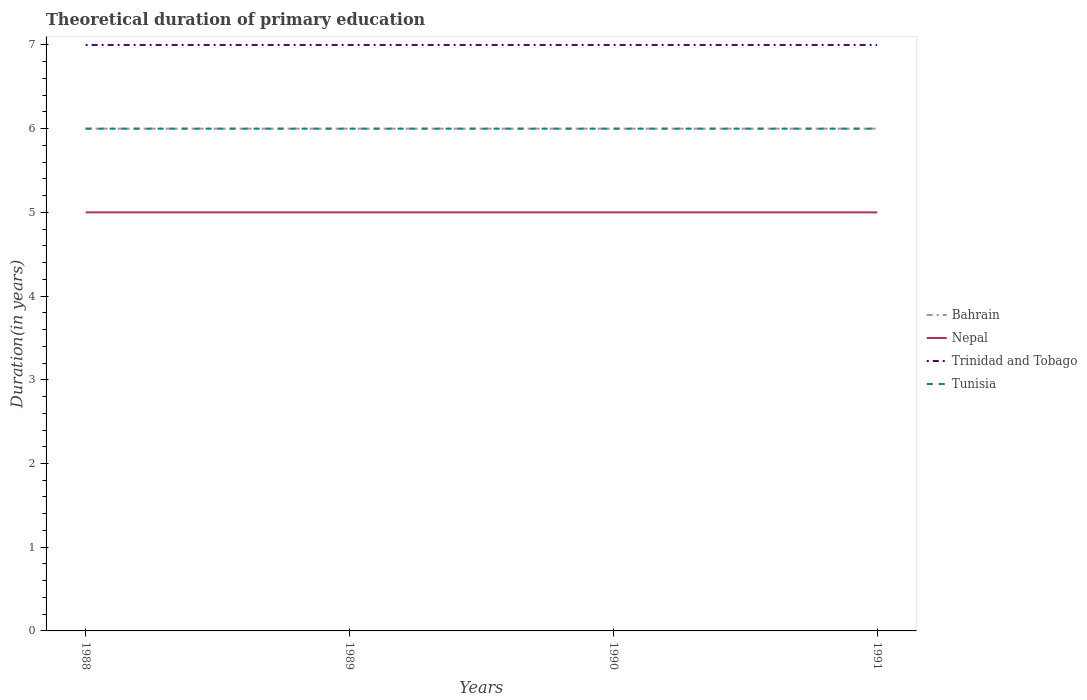Does the line corresponding to Tunisia intersect with the line corresponding to Nepal?
Your answer should be very brief. No. Is the number of lines equal to the number of legend labels?
Make the answer very short. Yes. Across all years, what is the maximum total theoretical duration of primary education in Trinidad and Tobago?
Give a very brief answer. 7. In which year was the total theoretical duration of primary education in Trinidad and Tobago maximum?
Make the answer very short. 1988. What is the total total theoretical duration of primary education in Tunisia in the graph?
Give a very brief answer. 0. What is the difference between the highest and the second highest total theoretical duration of primary education in Nepal?
Make the answer very short. 0. What is the difference between the highest and the lowest total theoretical duration of primary education in Bahrain?
Give a very brief answer. 0. How many lines are there?
Give a very brief answer. 4. How many years are there in the graph?
Offer a terse response. 4. Where does the legend appear in the graph?
Offer a terse response. Center right. What is the title of the graph?
Offer a terse response. Theoretical duration of primary education. What is the label or title of the Y-axis?
Your answer should be compact. Duration(in years). What is the Duration(in years) of Bahrain in 1988?
Give a very brief answer. 6. What is the Duration(in years) of Nepal in 1988?
Give a very brief answer. 5. What is the Duration(in years) in Bahrain in 1989?
Keep it short and to the point. 6. What is the Duration(in years) of Trinidad and Tobago in 1989?
Your answer should be very brief. 7. What is the Duration(in years) in Bahrain in 1990?
Ensure brevity in your answer.  6. What is the Duration(in years) in Trinidad and Tobago in 1990?
Give a very brief answer. 7. Across all years, what is the maximum Duration(in years) of Bahrain?
Offer a terse response. 6. Across all years, what is the maximum Duration(in years) in Tunisia?
Offer a very short reply. 6. Across all years, what is the minimum Duration(in years) of Bahrain?
Your answer should be very brief. 6. Across all years, what is the minimum Duration(in years) of Nepal?
Ensure brevity in your answer.  5. Across all years, what is the minimum Duration(in years) of Tunisia?
Your answer should be compact. 6. What is the total Duration(in years) in Nepal in the graph?
Provide a short and direct response. 20. What is the total Duration(in years) in Trinidad and Tobago in the graph?
Your answer should be compact. 28. What is the difference between the Duration(in years) in Nepal in 1988 and that in 1989?
Provide a succinct answer. 0. What is the difference between the Duration(in years) in Tunisia in 1988 and that in 1989?
Offer a terse response. 0. What is the difference between the Duration(in years) in Bahrain in 1988 and that in 1990?
Keep it short and to the point. 0. What is the difference between the Duration(in years) in Nepal in 1988 and that in 1990?
Ensure brevity in your answer.  0. What is the difference between the Duration(in years) in Trinidad and Tobago in 1988 and that in 1990?
Provide a short and direct response. 0. What is the difference between the Duration(in years) in Trinidad and Tobago in 1988 and that in 1991?
Offer a very short reply. 0. What is the difference between the Duration(in years) in Tunisia in 1988 and that in 1991?
Keep it short and to the point. 0. What is the difference between the Duration(in years) of Trinidad and Tobago in 1989 and that in 1990?
Ensure brevity in your answer.  0. What is the difference between the Duration(in years) of Tunisia in 1989 and that in 1990?
Make the answer very short. 0. What is the difference between the Duration(in years) of Bahrain in 1989 and that in 1991?
Keep it short and to the point. 0. What is the difference between the Duration(in years) of Nepal in 1989 and that in 1991?
Provide a short and direct response. 0. What is the difference between the Duration(in years) in Tunisia in 1989 and that in 1991?
Provide a succinct answer. 0. What is the difference between the Duration(in years) in Tunisia in 1990 and that in 1991?
Offer a very short reply. 0. What is the difference between the Duration(in years) in Bahrain in 1988 and the Duration(in years) in Nepal in 1989?
Make the answer very short. 1. What is the difference between the Duration(in years) of Bahrain in 1988 and the Duration(in years) of Tunisia in 1989?
Ensure brevity in your answer.  0. What is the difference between the Duration(in years) of Nepal in 1988 and the Duration(in years) of Trinidad and Tobago in 1989?
Your answer should be very brief. -2. What is the difference between the Duration(in years) in Nepal in 1988 and the Duration(in years) in Tunisia in 1989?
Keep it short and to the point. -1. What is the difference between the Duration(in years) of Bahrain in 1988 and the Duration(in years) of Trinidad and Tobago in 1990?
Your answer should be compact. -1. What is the difference between the Duration(in years) of Nepal in 1988 and the Duration(in years) of Tunisia in 1990?
Your answer should be compact. -1. What is the difference between the Duration(in years) in Bahrain in 1988 and the Duration(in years) in Tunisia in 1991?
Your response must be concise. 0. What is the difference between the Duration(in years) in Nepal in 1988 and the Duration(in years) in Tunisia in 1991?
Offer a very short reply. -1. What is the difference between the Duration(in years) of Trinidad and Tobago in 1988 and the Duration(in years) of Tunisia in 1991?
Provide a succinct answer. 1. What is the difference between the Duration(in years) in Nepal in 1989 and the Duration(in years) in Trinidad and Tobago in 1990?
Offer a terse response. -2. What is the difference between the Duration(in years) in Nepal in 1989 and the Duration(in years) in Tunisia in 1990?
Keep it short and to the point. -1. What is the difference between the Duration(in years) of Nepal in 1989 and the Duration(in years) of Trinidad and Tobago in 1991?
Make the answer very short. -2. What is the difference between the Duration(in years) in Nepal in 1989 and the Duration(in years) in Tunisia in 1991?
Your answer should be compact. -1. What is the difference between the Duration(in years) of Trinidad and Tobago in 1989 and the Duration(in years) of Tunisia in 1991?
Keep it short and to the point. 1. What is the difference between the Duration(in years) of Nepal in 1990 and the Duration(in years) of Trinidad and Tobago in 1991?
Ensure brevity in your answer.  -2. What is the difference between the Duration(in years) of Nepal in 1990 and the Duration(in years) of Tunisia in 1991?
Ensure brevity in your answer.  -1. What is the difference between the Duration(in years) in Trinidad and Tobago in 1990 and the Duration(in years) in Tunisia in 1991?
Your answer should be very brief. 1. What is the average Duration(in years) of Trinidad and Tobago per year?
Provide a short and direct response. 7. In the year 1988, what is the difference between the Duration(in years) in Bahrain and Duration(in years) in Nepal?
Your answer should be compact. 1. In the year 1988, what is the difference between the Duration(in years) of Bahrain and Duration(in years) of Trinidad and Tobago?
Offer a terse response. -1. In the year 1988, what is the difference between the Duration(in years) in Bahrain and Duration(in years) in Tunisia?
Make the answer very short. 0. In the year 1988, what is the difference between the Duration(in years) of Nepal and Duration(in years) of Trinidad and Tobago?
Ensure brevity in your answer.  -2. In the year 1988, what is the difference between the Duration(in years) of Nepal and Duration(in years) of Tunisia?
Provide a short and direct response. -1. In the year 1989, what is the difference between the Duration(in years) of Bahrain and Duration(in years) of Nepal?
Your answer should be very brief. 1. In the year 1989, what is the difference between the Duration(in years) in Bahrain and Duration(in years) in Tunisia?
Ensure brevity in your answer.  0. In the year 1989, what is the difference between the Duration(in years) of Nepal and Duration(in years) of Trinidad and Tobago?
Your response must be concise. -2. In the year 1990, what is the difference between the Duration(in years) in Bahrain and Duration(in years) in Nepal?
Make the answer very short. 1. In the year 1990, what is the difference between the Duration(in years) of Bahrain and Duration(in years) of Tunisia?
Give a very brief answer. 0. In the year 1990, what is the difference between the Duration(in years) of Trinidad and Tobago and Duration(in years) of Tunisia?
Offer a very short reply. 1. In the year 1991, what is the difference between the Duration(in years) in Bahrain and Duration(in years) in Nepal?
Make the answer very short. 1. In the year 1991, what is the difference between the Duration(in years) in Bahrain and Duration(in years) in Trinidad and Tobago?
Your answer should be very brief. -1. In the year 1991, what is the difference between the Duration(in years) of Nepal and Duration(in years) of Trinidad and Tobago?
Offer a very short reply. -2. What is the ratio of the Duration(in years) in Bahrain in 1988 to that in 1990?
Your answer should be compact. 1. What is the ratio of the Duration(in years) of Nepal in 1988 to that in 1990?
Your answer should be very brief. 1. What is the ratio of the Duration(in years) of Nepal in 1988 to that in 1991?
Make the answer very short. 1. What is the ratio of the Duration(in years) in Trinidad and Tobago in 1988 to that in 1991?
Ensure brevity in your answer.  1. What is the ratio of the Duration(in years) of Tunisia in 1988 to that in 1991?
Offer a terse response. 1. What is the ratio of the Duration(in years) in Trinidad and Tobago in 1989 to that in 1990?
Offer a terse response. 1. What is the ratio of the Duration(in years) in Tunisia in 1989 to that in 1990?
Offer a very short reply. 1. What is the ratio of the Duration(in years) of Nepal in 1989 to that in 1991?
Give a very brief answer. 1. What is the ratio of the Duration(in years) of Tunisia in 1989 to that in 1991?
Offer a terse response. 1. What is the ratio of the Duration(in years) of Bahrain in 1990 to that in 1991?
Offer a terse response. 1. What is the ratio of the Duration(in years) of Trinidad and Tobago in 1990 to that in 1991?
Your response must be concise. 1. What is the difference between the highest and the second highest Duration(in years) of Nepal?
Offer a terse response. 0. What is the difference between the highest and the second highest Duration(in years) of Tunisia?
Offer a very short reply. 0. What is the difference between the highest and the lowest Duration(in years) of Nepal?
Provide a short and direct response. 0. 